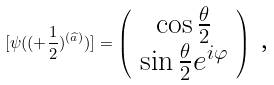<formula> <loc_0><loc_0><loc_500><loc_500>[ \psi ( ( + \frac { 1 } { 2 } ) ^ { ( \widehat { a } ) } ) ] = \left ( \begin{array} { c } \cos \frac { \theta } { 2 } \\ \sin \frac { \theta } { 2 } e ^ { i \varphi } \end{array} \right ) \text { ,}</formula> 